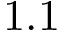Convert formula to latex. <formula><loc_0><loc_0><loc_500><loc_500>1 . 1</formula> 